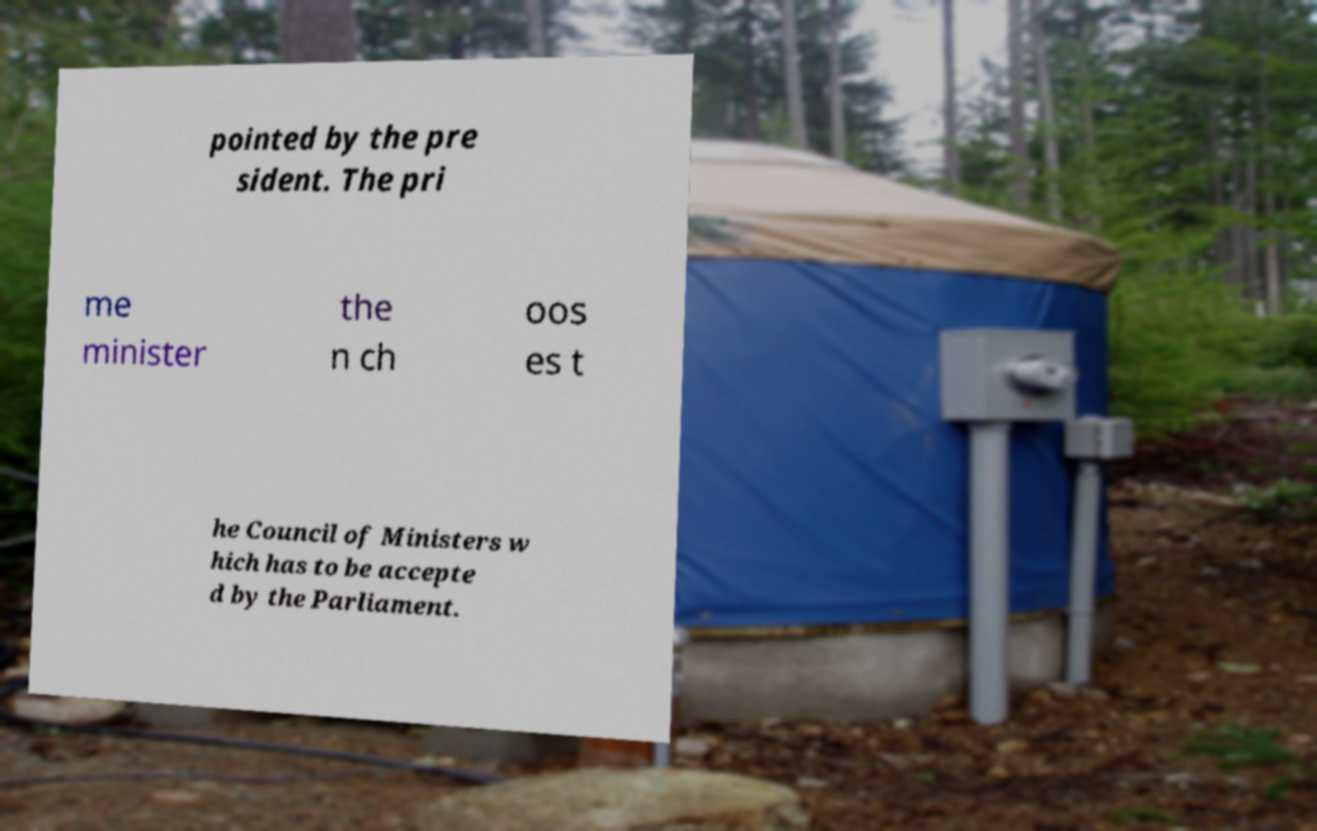Please identify and transcribe the text found in this image. pointed by the pre sident. The pri me minister the n ch oos es t he Council of Ministers w hich has to be accepte d by the Parliament. 